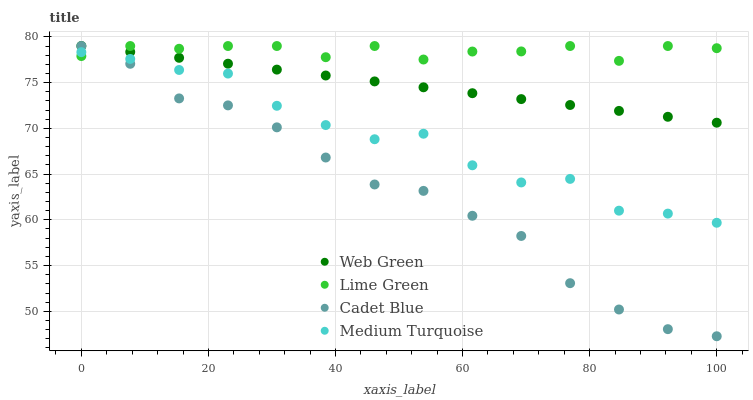Does Cadet Blue have the minimum area under the curve?
Answer yes or no. Yes. Does Lime Green have the maximum area under the curve?
Answer yes or no. Yes. Does Medium Turquoise have the minimum area under the curve?
Answer yes or no. No. Does Medium Turquoise have the maximum area under the curve?
Answer yes or no. No. Is Web Green the smoothest?
Answer yes or no. Yes. Is Medium Turquoise the roughest?
Answer yes or no. Yes. Is Lime Green the smoothest?
Answer yes or no. No. Is Lime Green the roughest?
Answer yes or no. No. Does Cadet Blue have the lowest value?
Answer yes or no. Yes. Does Medium Turquoise have the lowest value?
Answer yes or no. No. Does Web Green have the highest value?
Answer yes or no. Yes. Does Medium Turquoise have the highest value?
Answer yes or no. No. Is Medium Turquoise less than Web Green?
Answer yes or no. Yes. Is Web Green greater than Medium Turquoise?
Answer yes or no. Yes. Does Medium Turquoise intersect Cadet Blue?
Answer yes or no. Yes. Is Medium Turquoise less than Cadet Blue?
Answer yes or no. No. Is Medium Turquoise greater than Cadet Blue?
Answer yes or no. No. Does Medium Turquoise intersect Web Green?
Answer yes or no. No. 